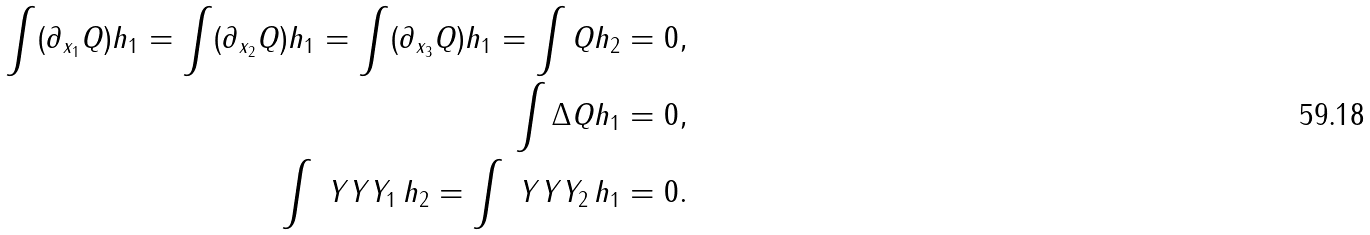Convert formula to latex. <formula><loc_0><loc_0><loc_500><loc_500>\int ( \partial _ { x _ { 1 } } Q ) h _ { 1 } = \int ( \partial _ { x _ { 2 } } Q ) h _ { 1 } = \int ( \partial _ { x _ { 3 } } Q ) h _ { 1 } = \int Q h _ { 2 } = 0 , \\ \int \Delta Q h _ { 1 } = 0 , \\ \int \ Y Y Y _ { 1 } \, h _ { 2 } = \int \ Y Y Y _ { 2 } \, h _ { 1 } = 0 .</formula> 